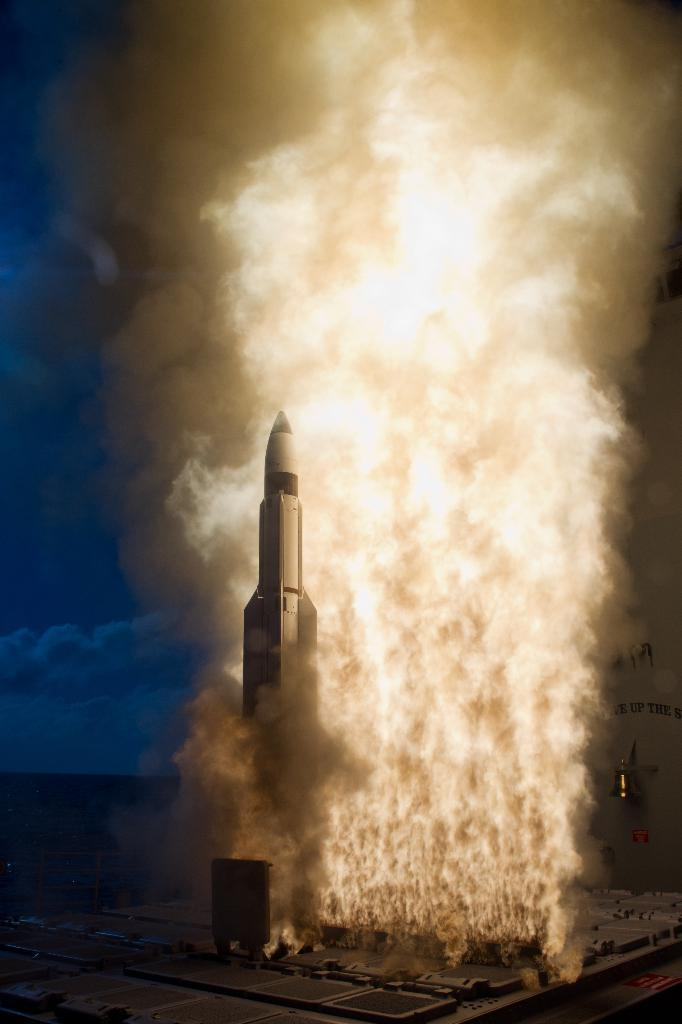What is the main subject in the center of the image? There is a rocket in the center of the image. What can be seen near the rocket? There is fire in the image. What is visible in the background of the image? There is a white object in the background of the image. How would you describe the sky in the image? The sky is cloudy in the image. Can you see any snails crawling on the rocket in the image? No, there are no snails visible on the rocket in the image. 